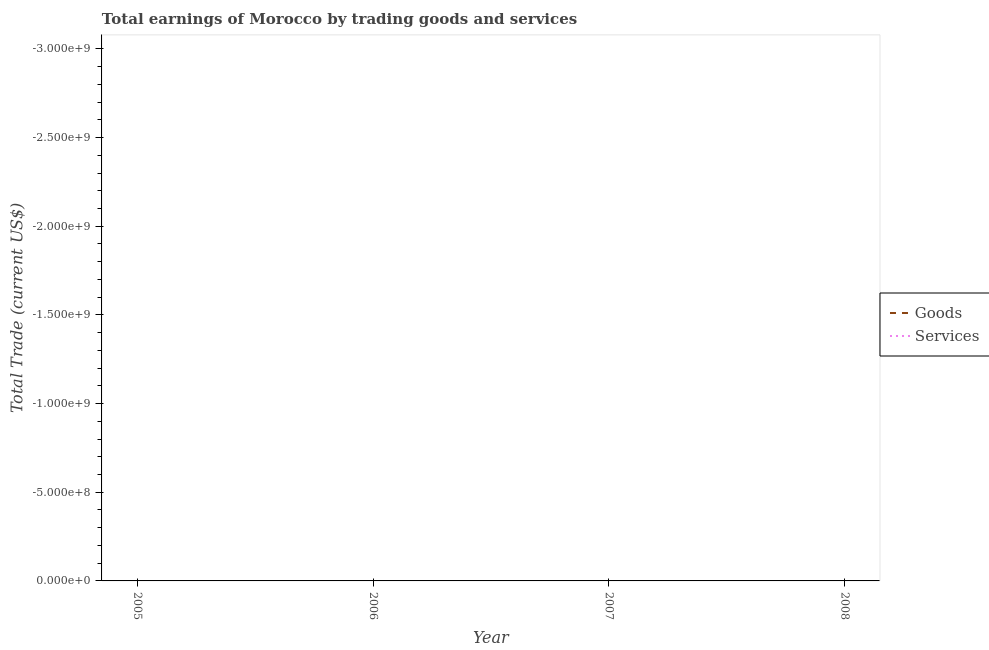How many different coloured lines are there?
Keep it short and to the point. 0. Does the line corresponding to amount earned by trading goods intersect with the line corresponding to amount earned by trading services?
Offer a terse response. No. Is the number of lines equal to the number of legend labels?
Make the answer very short. No. What is the amount earned by trading services in 2008?
Give a very brief answer. 0. Across all years, what is the minimum amount earned by trading goods?
Your answer should be very brief. 0. What is the total amount earned by trading goods in the graph?
Give a very brief answer. 0. What is the difference between the amount earned by trading services in 2008 and the amount earned by trading goods in 2007?
Provide a short and direct response. 0. In how many years, is the amount earned by trading services greater than -2200000000 US$?
Your answer should be very brief. 0. In how many years, is the amount earned by trading services greater than the average amount earned by trading services taken over all years?
Provide a succinct answer. 0. Is the amount earned by trading services strictly greater than the amount earned by trading goods over the years?
Provide a short and direct response. Yes. Is the amount earned by trading goods strictly less than the amount earned by trading services over the years?
Offer a very short reply. Yes. How many years are there in the graph?
Ensure brevity in your answer.  4. Are the values on the major ticks of Y-axis written in scientific E-notation?
Your response must be concise. Yes. Does the graph contain any zero values?
Make the answer very short. Yes. Does the graph contain grids?
Ensure brevity in your answer.  No. Where does the legend appear in the graph?
Ensure brevity in your answer.  Center right. How are the legend labels stacked?
Make the answer very short. Vertical. What is the title of the graph?
Provide a succinct answer. Total earnings of Morocco by trading goods and services. What is the label or title of the X-axis?
Make the answer very short. Year. What is the label or title of the Y-axis?
Provide a short and direct response. Total Trade (current US$). What is the Total Trade (current US$) in Services in 2006?
Your answer should be compact. 0. What is the Total Trade (current US$) of Services in 2007?
Your answer should be very brief. 0. What is the Total Trade (current US$) in Goods in 2008?
Provide a succinct answer. 0. What is the Total Trade (current US$) of Services in 2008?
Keep it short and to the point. 0. What is the average Total Trade (current US$) of Goods per year?
Give a very brief answer. 0. What is the average Total Trade (current US$) of Services per year?
Your response must be concise. 0. 